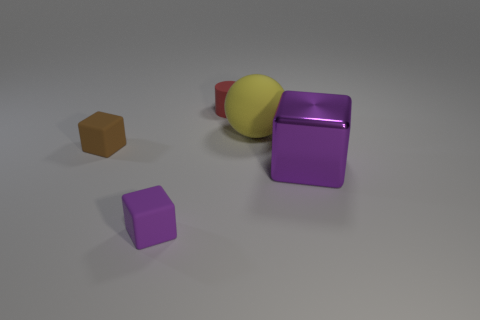Add 3 big shiny things. How many objects exist? 8 Subtract all cylinders. How many objects are left? 4 Add 5 brown things. How many brown things are left? 6 Add 3 large blue metallic cubes. How many large blue metallic cubes exist? 3 Subtract 0 gray cylinders. How many objects are left? 5 Subtract all green objects. Subtract all small cylinders. How many objects are left? 4 